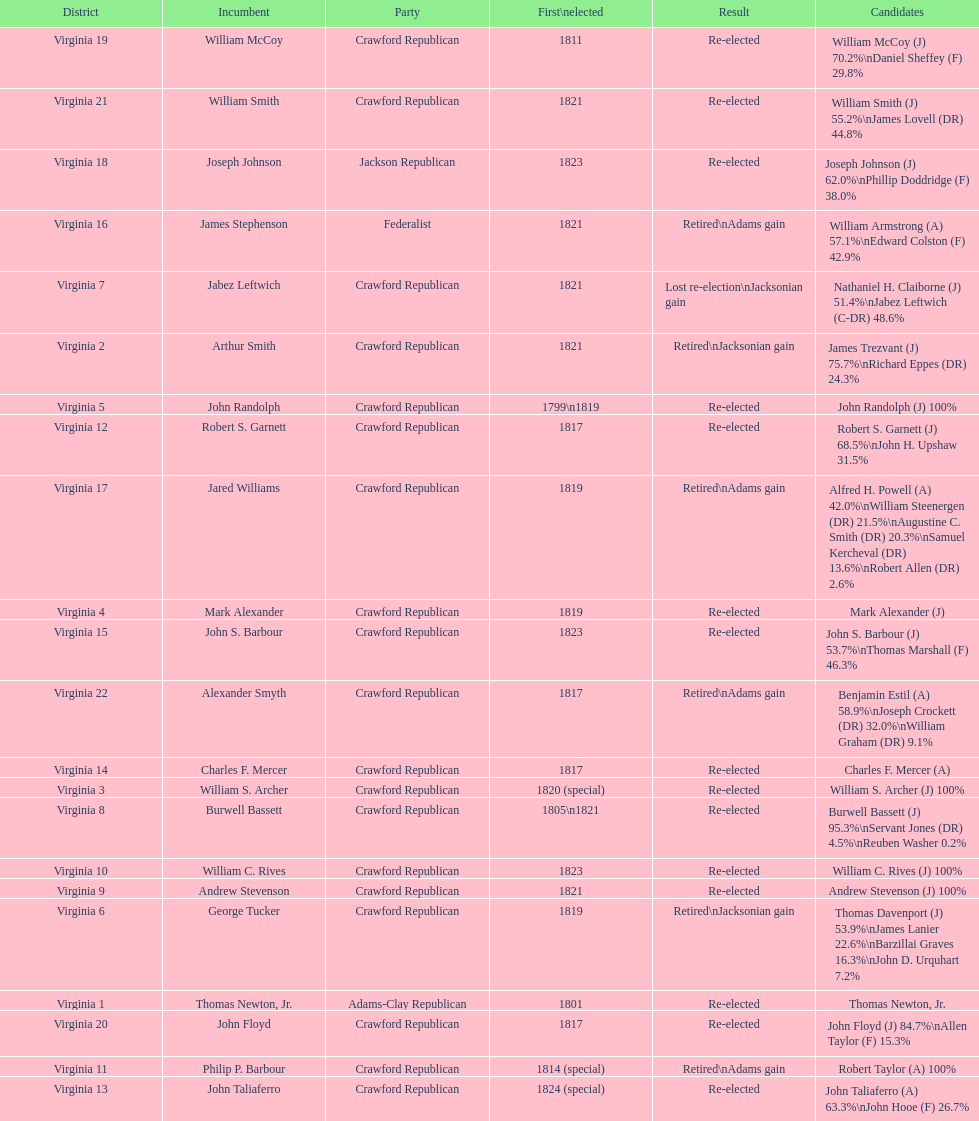Could you help me parse every detail presented in this table? {'header': ['District', 'Incumbent', 'Party', 'First\\nelected', 'Result', 'Candidates'], 'rows': [['Virginia 19', 'William McCoy', 'Crawford Republican', '1811', 'Re-elected', 'William McCoy (J) 70.2%\\nDaniel Sheffey (F) 29.8%'], ['Virginia 21', 'William Smith', 'Crawford Republican', '1821', 'Re-elected', 'William Smith (J) 55.2%\\nJames Lovell (DR) 44.8%'], ['Virginia 18', 'Joseph Johnson', 'Jackson Republican', '1823', 'Re-elected', 'Joseph Johnson (J) 62.0%\\nPhillip Doddridge (F) 38.0%'], ['Virginia 16', 'James Stephenson', 'Federalist', '1821', 'Retired\\nAdams gain', 'William Armstrong (A) 57.1%\\nEdward Colston (F) 42.9%'], ['Virginia 7', 'Jabez Leftwich', 'Crawford Republican', '1821', 'Lost re-election\\nJacksonian gain', 'Nathaniel H. Claiborne (J) 51.4%\\nJabez Leftwich (C-DR) 48.6%'], ['Virginia 2', 'Arthur Smith', 'Crawford Republican', '1821', 'Retired\\nJacksonian gain', 'James Trezvant (J) 75.7%\\nRichard Eppes (DR) 24.3%'], ['Virginia 5', 'John Randolph', 'Crawford Republican', '1799\\n1819', 'Re-elected', 'John Randolph (J) 100%'], ['Virginia 12', 'Robert S. Garnett', 'Crawford Republican', '1817', 'Re-elected', 'Robert S. Garnett (J) 68.5%\\nJohn H. Upshaw 31.5%'], ['Virginia 17', 'Jared Williams', 'Crawford Republican', '1819', 'Retired\\nAdams gain', 'Alfred H. Powell (A) 42.0%\\nWilliam Steenergen (DR) 21.5%\\nAugustine C. Smith (DR) 20.3%\\nSamuel Kercheval (DR) 13.6%\\nRobert Allen (DR) 2.6%'], ['Virginia 4', 'Mark Alexander', 'Crawford Republican', '1819', 'Re-elected', 'Mark Alexander (J)'], ['Virginia 15', 'John S. Barbour', 'Crawford Republican', '1823', 'Re-elected', 'John S. Barbour (J) 53.7%\\nThomas Marshall (F) 46.3%'], ['Virginia 22', 'Alexander Smyth', 'Crawford Republican', '1817', 'Retired\\nAdams gain', 'Benjamin Estil (A) 58.9%\\nJoseph Crockett (DR) 32.0%\\nWilliam Graham (DR) 9.1%'], ['Virginia 14', 'Charles F. Mercer', 'Crawford Republican', '1817', 'Re-elected', 'Charles F. Mercer (A)'], ['Virginia 3', 'William S. Archer', 'Crawford Republican', '1820 (special)', 'Re-elected', 'William S. Archer (J) 100%'], ['Virginia 8', 'Burwell Bassett', 'Crawford Republican', '1805\\n1821', 'Re-elected', 'Burwell Bassett (J) 95.3%\\nServant Jones (DR) 4.5%\\nReuben Washer 0.2%'], ['Virginia 10', 'William C. Rives', 'Crawford Republican', '1823', 'Re-elected', 'William C. Rives (J) 100%'], ['Virginia 9', 'Andrew Stevenson', 'Crawford Republican', '1821', 'Re-elected', 'Andrew Stevenson (J) 100%'], ['Virginia 6', 'George Tucker', 'Crawford Republican', '1819', 'Retired\\nJacksonian gain', 'Thomas Davenport (J) 53.9%\\nJames Lanier 22.6%\\nBarzillai Graves 16.3%\\nJohn D. Urquhart 7.2%'], ['Virginia 1', 'Thomas Newton, Jr.', 'Adams-Clay Republican', '1801', 'Re-elected', 'Thomas Newton, Jr.'], ['Virginia 20', 'John Floyd', 'Crawford Republican', '1817', 'Re-elected', 'John Floyd (J) 84.7%\\nAllen Taylor (F) 15.3%'], ['Virginia 11', 'Philip P. Barbour', 'Crawford Republican', '1814 (special)', 'Retired\\nAdams gain', 'Robert Taylor (A) 100%'], ['Virginia 13', 'John Taliaferro', 'Crawford Republican', '1824 (special)', 'Re-elected', 'John Taliaferro (A) 63.3%\\nJohn Hooe (F) 26.7%']]} What is the last party on this chart? Crawford Republican. 